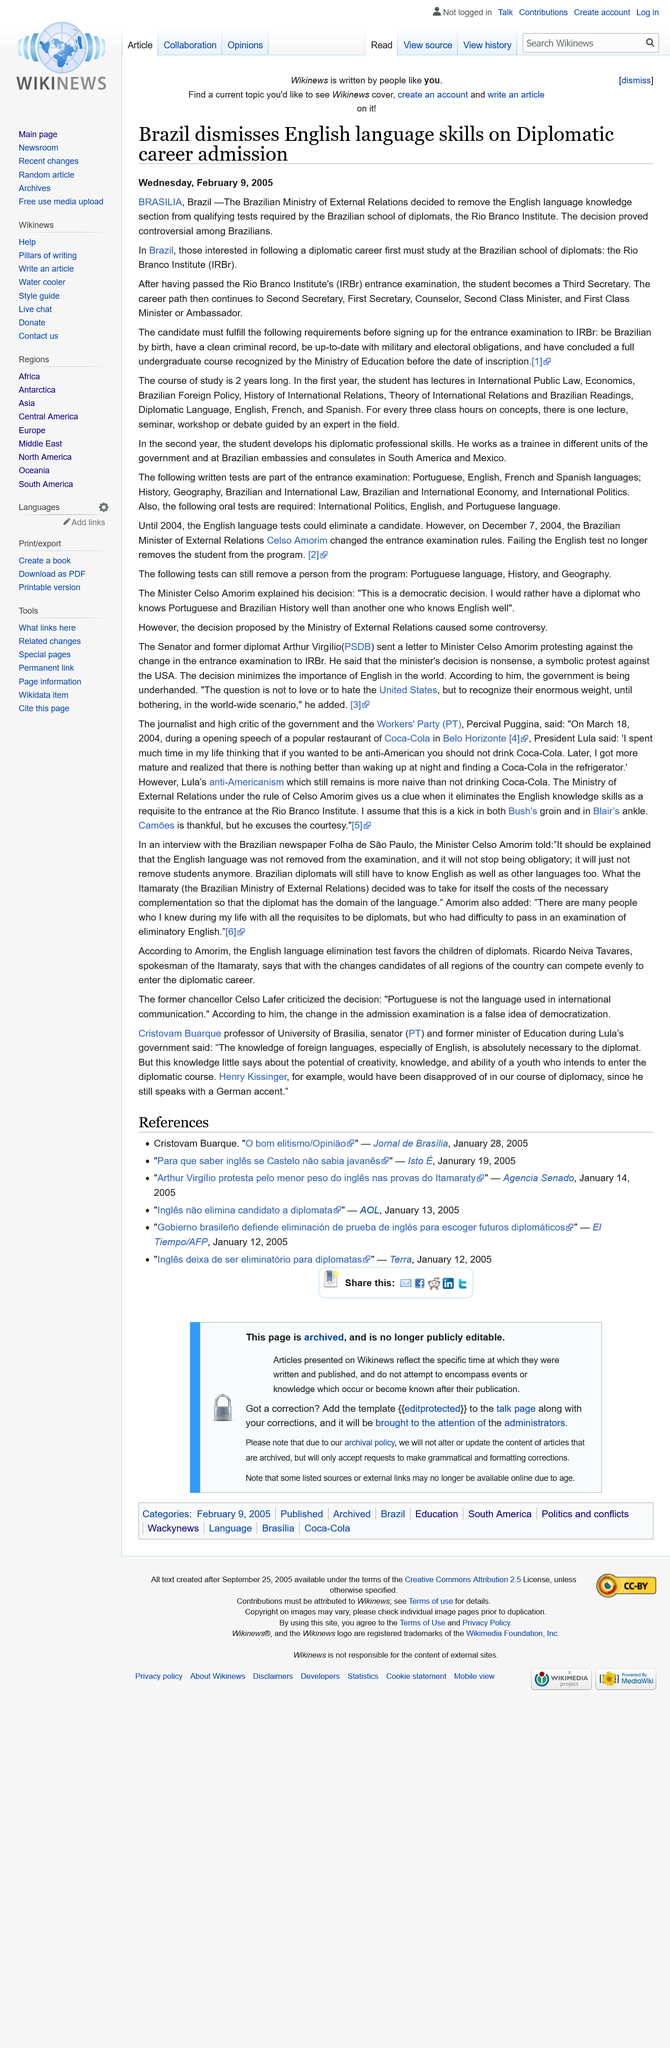Specify some key components in this picture. The Brazilian Ministry of External Relations has removed the English language requirement for entry into diplomat careers. The course of study to become a diplomat in Brazil is 2 years long. The Brazilian school of diplomats is known as the Rio Branco Institute. 